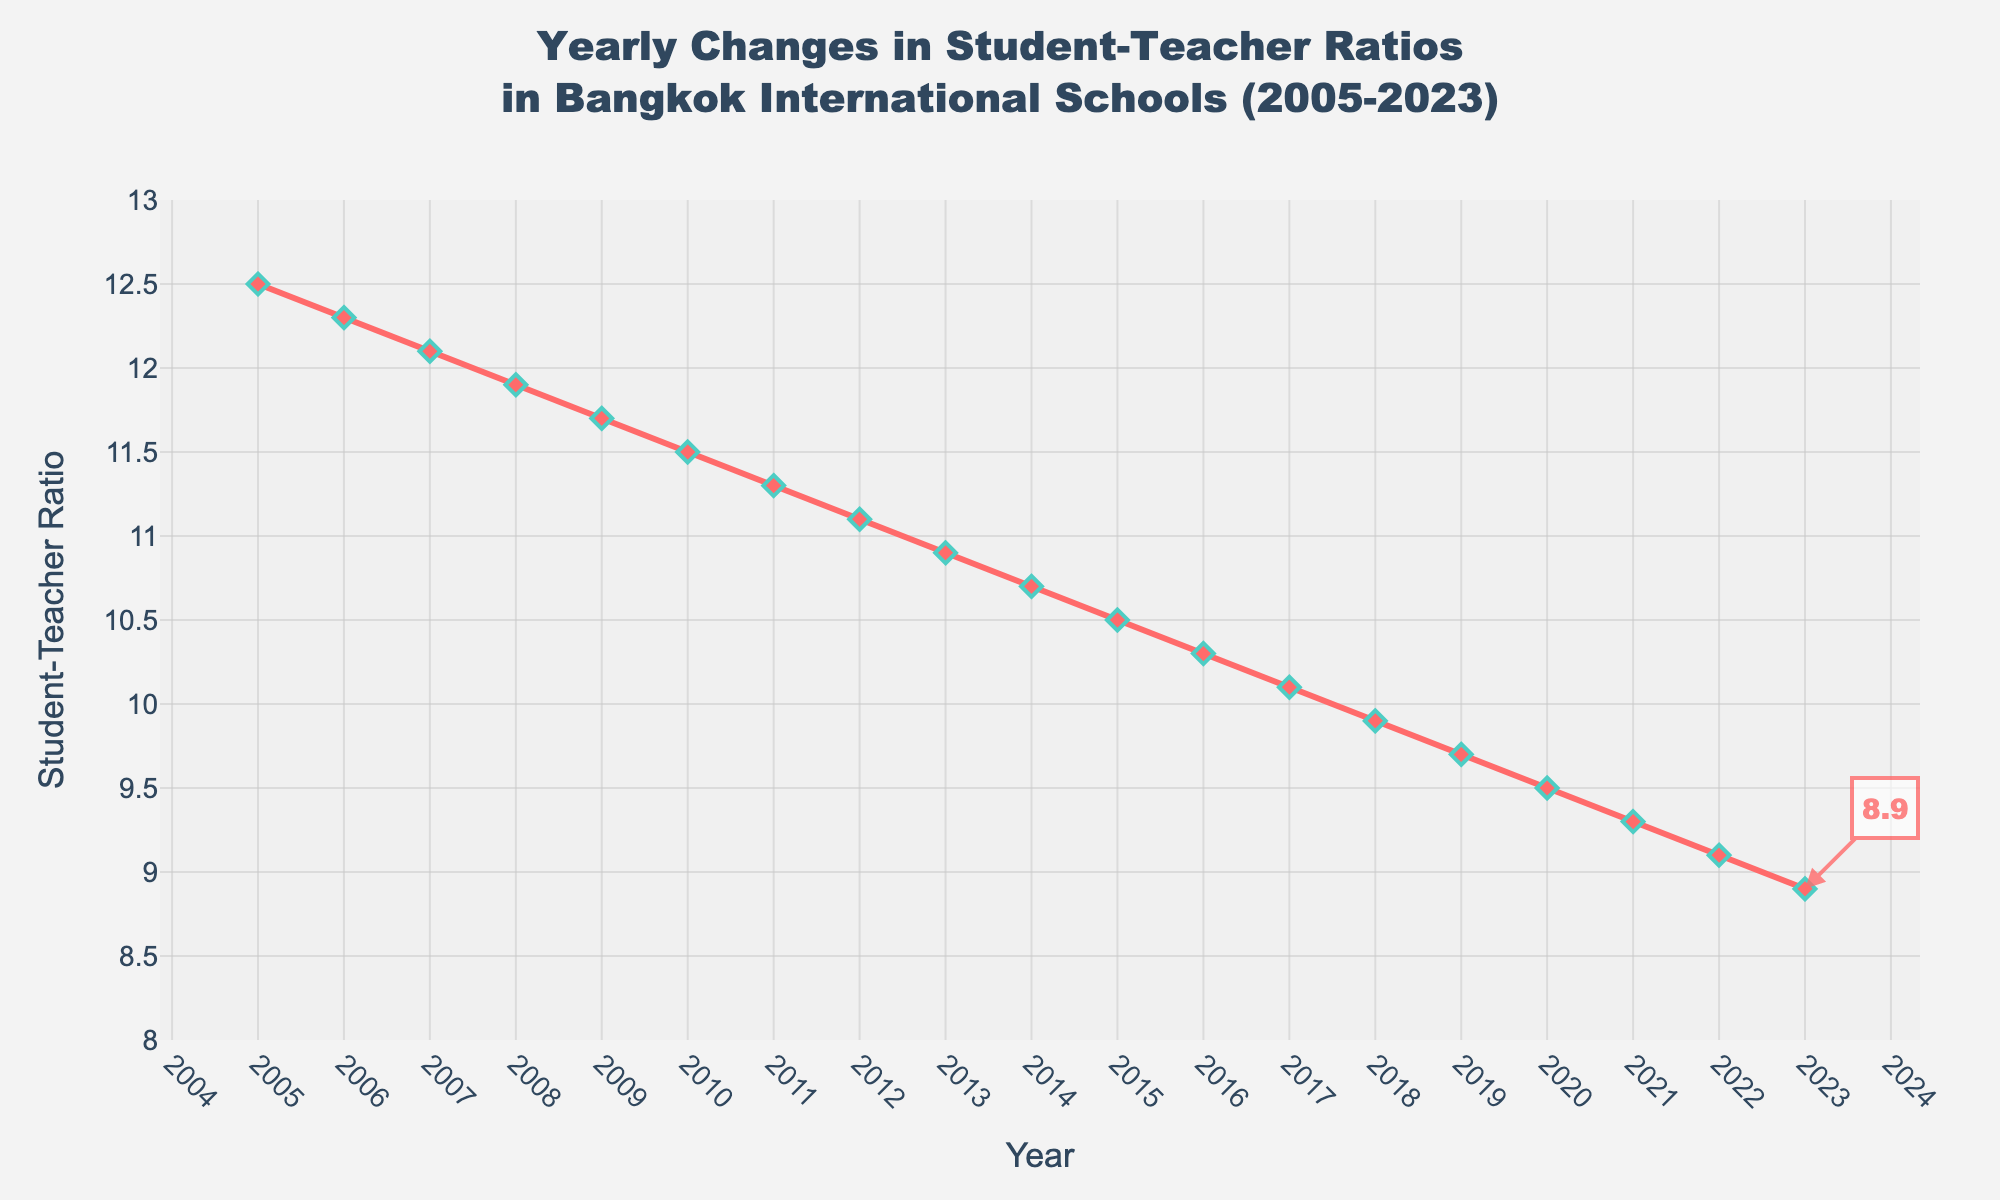Which year has the lowest student-teacher ratio? The year with the lowest ratio can be found by looking at the point on the line with the smallest value on the y-axis. This appears in 2023.
Answer: 2023 How does the student-teacher ratio in 2005 compare to 2023? The student-teacher ratio in 2005 is 12.5, while in 2023 it drops to 8.9. The difference is found by subtracting 8.9 from 12.5.
Answer: 3.6 units lower What's the trend in student-teacher ratios from 2005 to 2023? The trend can be observed by looking at the general direction of the line from 2005 to 2023. The line slopes downward consistently, indicating a decreasing trend.
Answer: Decreasing What is the difference in the student-teacher ratio between 2006 and 2016? The student-teacher ratio in 2006 is 12.3, and in 2016 it is 10.3. Subtract 10.3 from 12.3 to find the difference.
Answer: 2 units Which year shows the most significant decrease in the student-teacher ratio compared to the previous year? By examining the slope between each pair of consecutive points, the steepest decline occurs between 2005 and 2006, where the ratio drops by 0.2 units.
Answer: 2005-2006 What is the average student-teacher ratio from 2005 to 2023? To find the average, sum all the yearly ratios and divide by the number of years. (12.5 + 12.3 + 12.1 + 11.9 + 11.7 + 11.5 + 11.3 + 11.1 + 10.9 + 10.7 + 10.5 + 10.3 + 10.1 + 9.9 + 9.7 + 9.5 + 9.3 + 9.1 + 8.9) / 19 years = 10.75
Answer: 10.75 By how much did the student-teacher ratio decrease from 2007 to 2018? In 2007, the ratio is 12.1, and in 2018 it is 9.9. Subtracting 9.9 from 12.1 gives the difference.
Answer: 2.2 units Between which two consecutive years did the student-teacher ratio remain the same? Looking at the graph, there is no point where the line is flat between two consecutive years, suggesting it always changes.
Answer: No years How much did the student-teacher ratio decrease between 2019 and 2021? The student-teacher ratio in 2019 is 9.7, and in 2021 it is 9.3. Subtract 9.3 from 9.7.
Answer: 0.4 units By what percentage did the student-teacher ratio decrease from 2005 to 2023? Calculate the percentage decrease: ((12.5 - 8.9) / 12.5) * 100 = 28.8%
Answer: 28.8% 